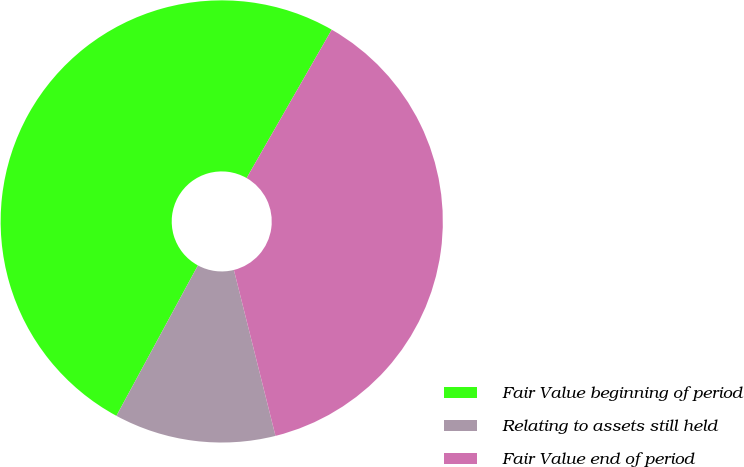Convert chart to OTSL. <chart><loc_0><loc_0><loc_500><loc_500><pie_chart><fcel>Fair Value beginning of period<fcel>Relating to assets still held<fcel>Fair Value end of period<nl><fcel>50.39%<fcel>11.81%<fcel>37.8%<nl></chart> 